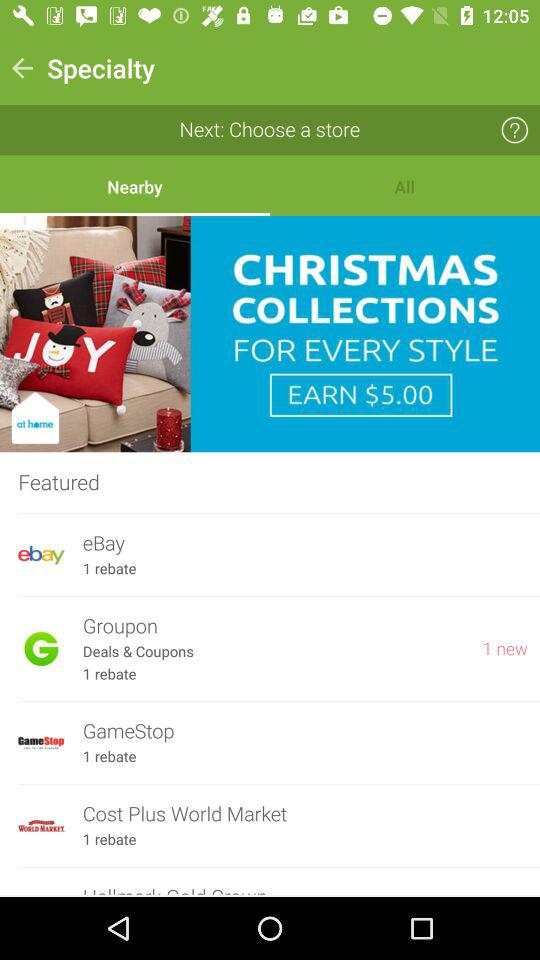What is the earn amount on Christmas collections? The earning amount is $ 5.00. 